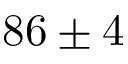<formula> <loc_0><loc_0><loc_500><loc_500>8 6 \pm 4</formula> 